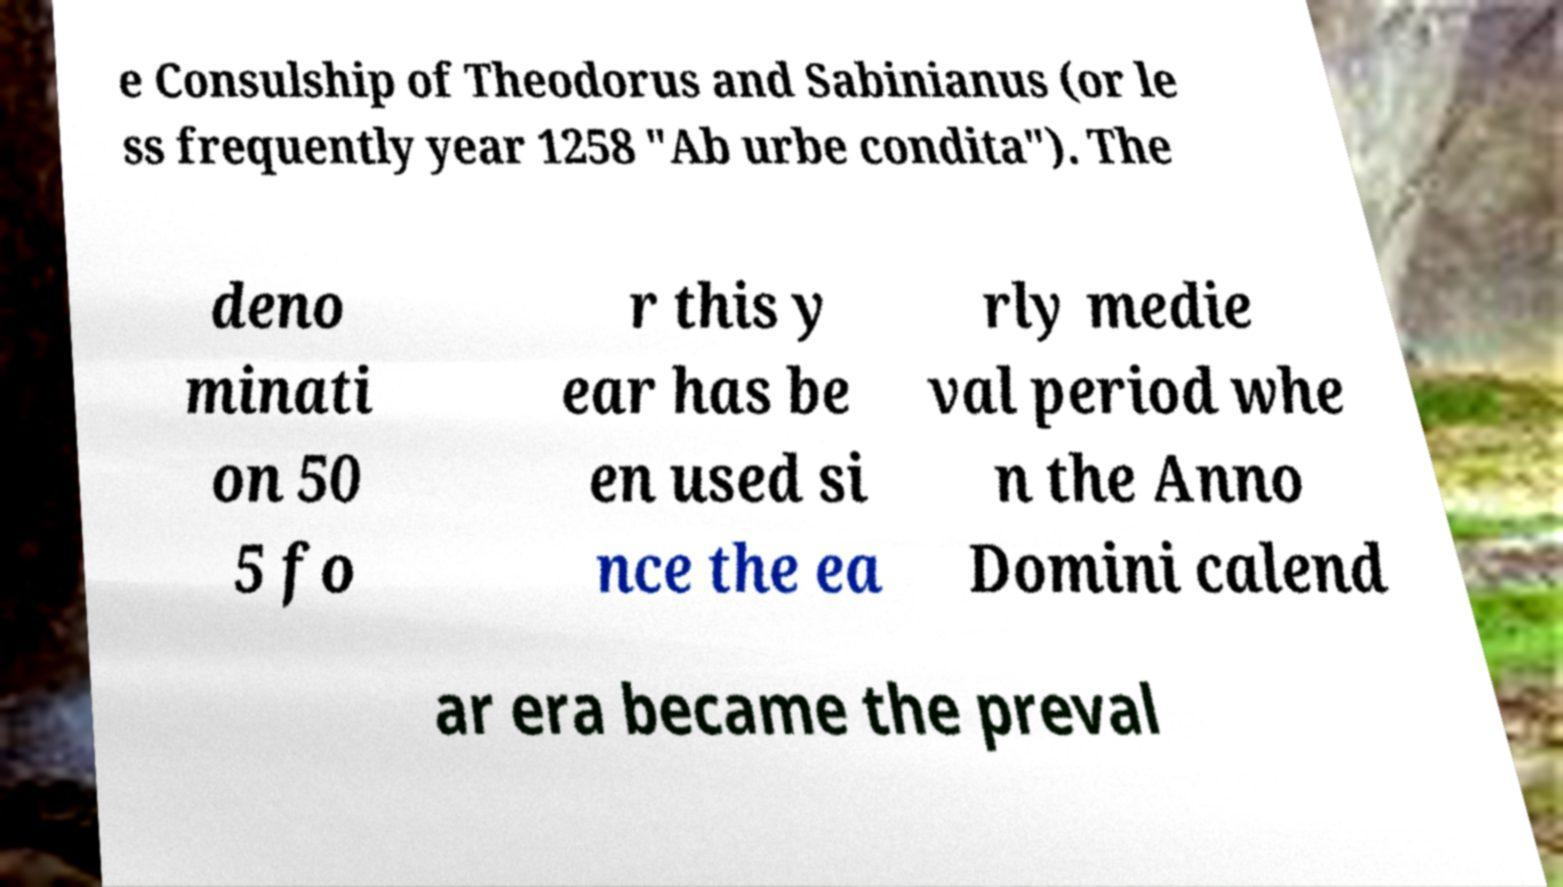Could you extract and type out the text from this image? e Consulship of Theodorus and Sabinianus (or le ss frequently year 1258 "Ab urbe condita"). The deno minati on 50 5 fo r this y ear has be en used si nce the ea rly medie val period whe n the Anno Domini calend ar era became the preval 